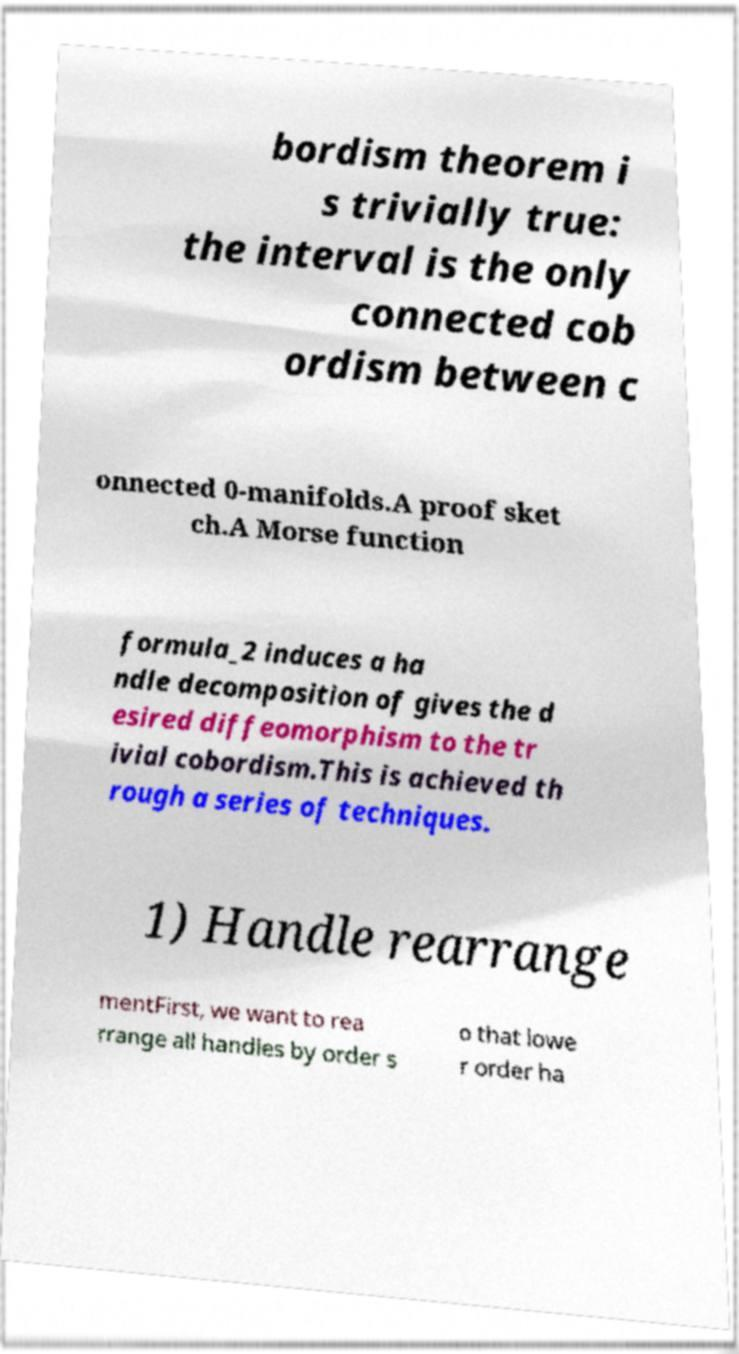Please read and relay the text visible in this image. What does it say? bordism theorem i s trivially true: the interval is the only connected cob ordism between c onnected 0-manifolds.A proof sket ch.A Morse function formula_2 induces a ha ndle decomposition of gives the d esired diffeomorphism to the tr ivial cobordism.This is achieved th rough a series of techniques. 1) Handle rearrange mentFirst, we want to rea rrange all handles by order s o that lowe r order ha 